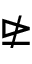Convert formula to latex. <formula><loc_0><loc_0><loc_500><loc_500>\ntrianglerighteq</formula> 